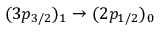<formula> <loc_0><loc_0><loc_500><loc_500>( 3 p _ { 3 / 2 } ) _ { 1 } \rightarrow ( 2 p _ { 1 / 2 } ) _ { 0 }</formula> 